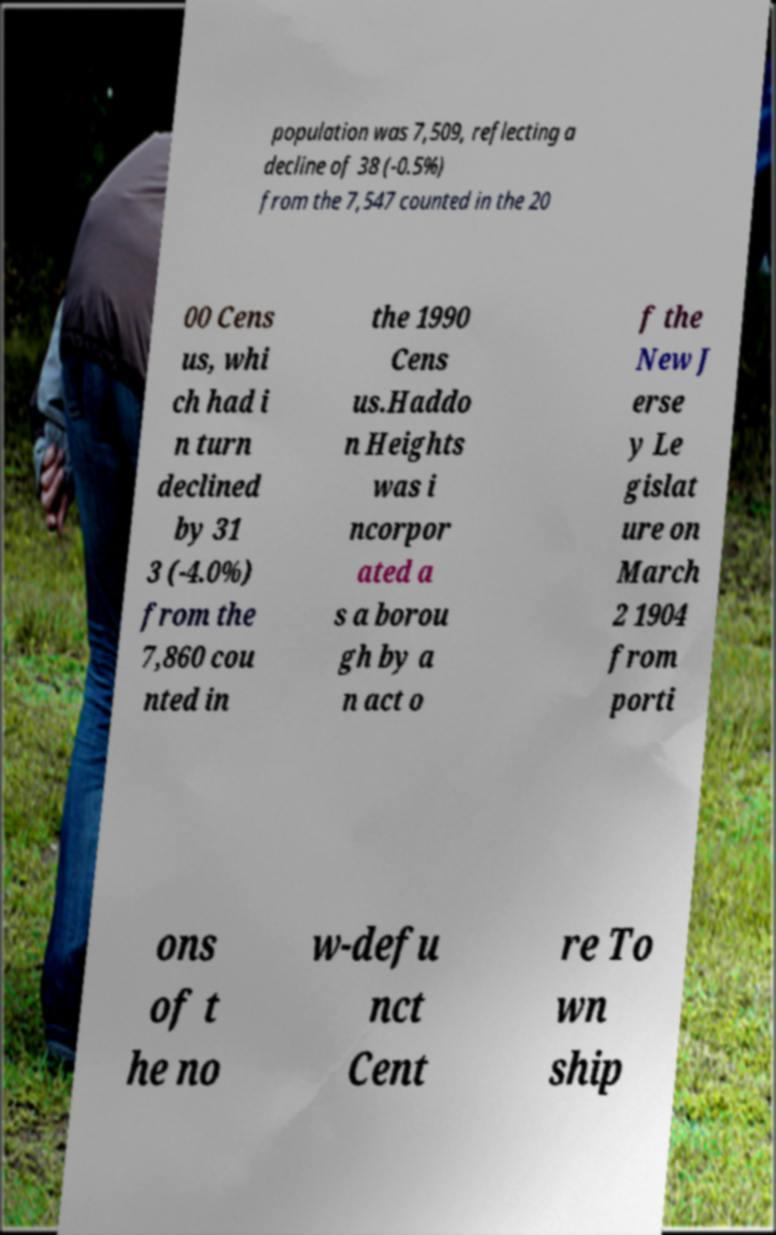For documentation purposes, I need the text within this image transcribed. Could you provide that? population was 7,509, reflecting a decline of 38 (-0.5%) from the 7,547 counted in the 20 00 Cens us, whi ch had i n turn declined by 31 3 (-4.0%) from the 7,860 cou nted in the 1990 Cens us.Haddo n Heights was i ncorpor ated a s a borou gh by a n act o f the New J erse y Le gislat ure on March 2 1904 from porti ons of t he no w-defu nct Cent re To wn ship 